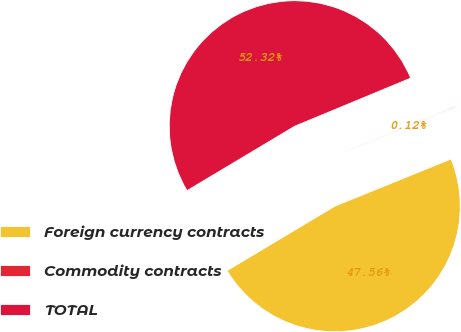Convert chart to OTSL. <chart><loc_0><loc_0><loc_500><loc_500><pie_chart><fcel>Foreign currency contracts<fcel>Commodity contracts<fcel>TOTAL<nl><fcel>47.56%<fcel>0.12%<fcel>52.32%<nl></chart> 